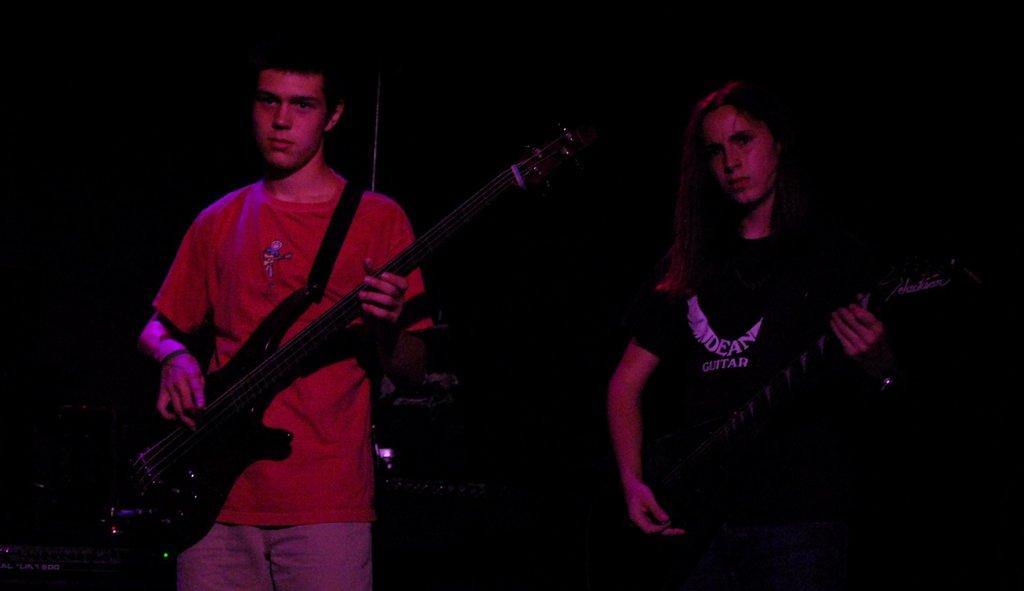How many people are in the image? There are two persons in the image. What are the persons holding in the image? Both persons are holding guitars. What type of road can be seen in the background of the image? There is no road visible in the image; it only features two persons holding guitars. 